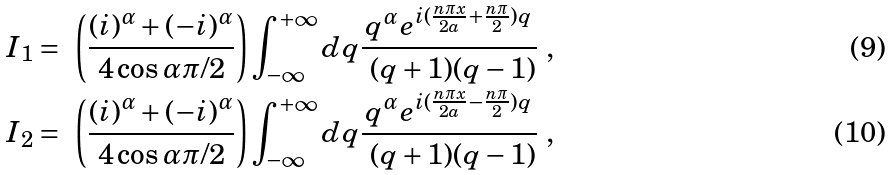Convert formula to latex. <formula><loc_0><loc_0><loc_500><loc_500>I _ { 1 } & = \ \left ( \frac { ( i ) ^ { \alpha } + ( - i ) ^ { \alpha } } { 4 \cos \alpha \pi / 2 } \right ) \int _ { - \infty } ^ { + \infty } d q \frac { q ^ { \alpha } e ^ { i ( \frac { n \pi x } { 2 a } + \frac { n \pi } { 2 } ) q } } { \ ( q + 1 ) ( q - 1 ) } \ , \\ I _ { 2 } & = \ \left ( \frac { ( i ) ^ { \alpha } + ( - i ) ^ { \alpha } } { 4 \cos \alpha \pi / 2 } \right ) \int _ { - \infty } ^ { + \infty } d q \frac { q ^ { \alpha } e ^ { i ( \frac { n \pi x } { 2 a } - \frac { n \pi } { 2 } ) q } } { \ ( q + 1 ) ( q - 1 ) } \ ,</formula> 